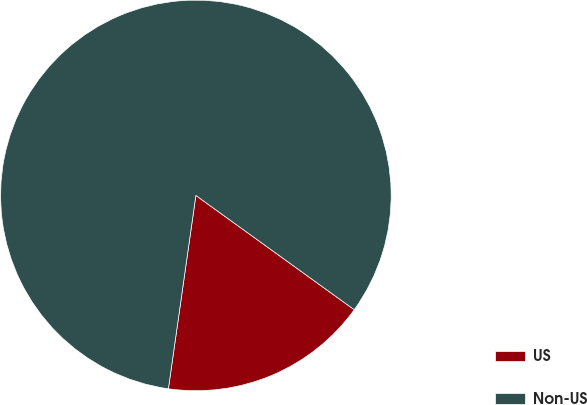Convert chart to OTSL. <chart><loc_0><loc_0><loc_500><loc_500><pie_chart><fcel>US<fcel>Non-US<nl><fcel>17.3%<fcel>82.7%<nl></chart> 